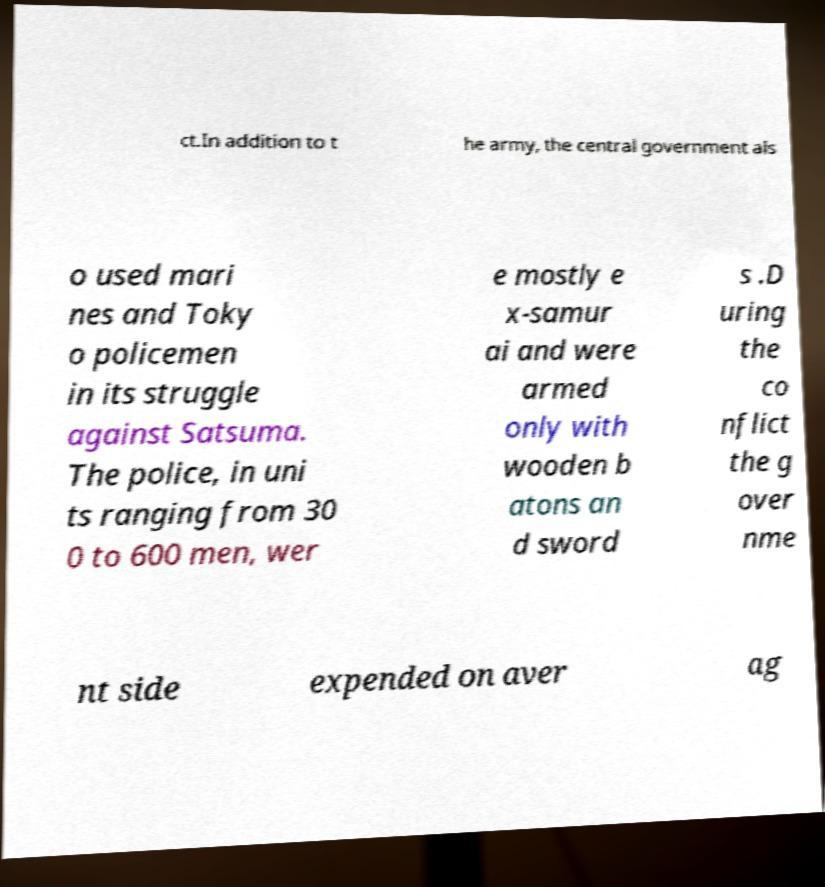Can you read and provide the text displayed in the image?This photo seems to have some interesting text. Can you extract and type it out for me? ct.In addition to t he army, the central government als o used mari nes and Toky o policemen in its struggle against Satsuma. The police, in uni ts ranging from 30 0 to 600 men, wer e mostly e x-samur ai and were armed only with wooden b atons an d sword s .D uring the co nflict the g over nme nt side expended on aver ag 